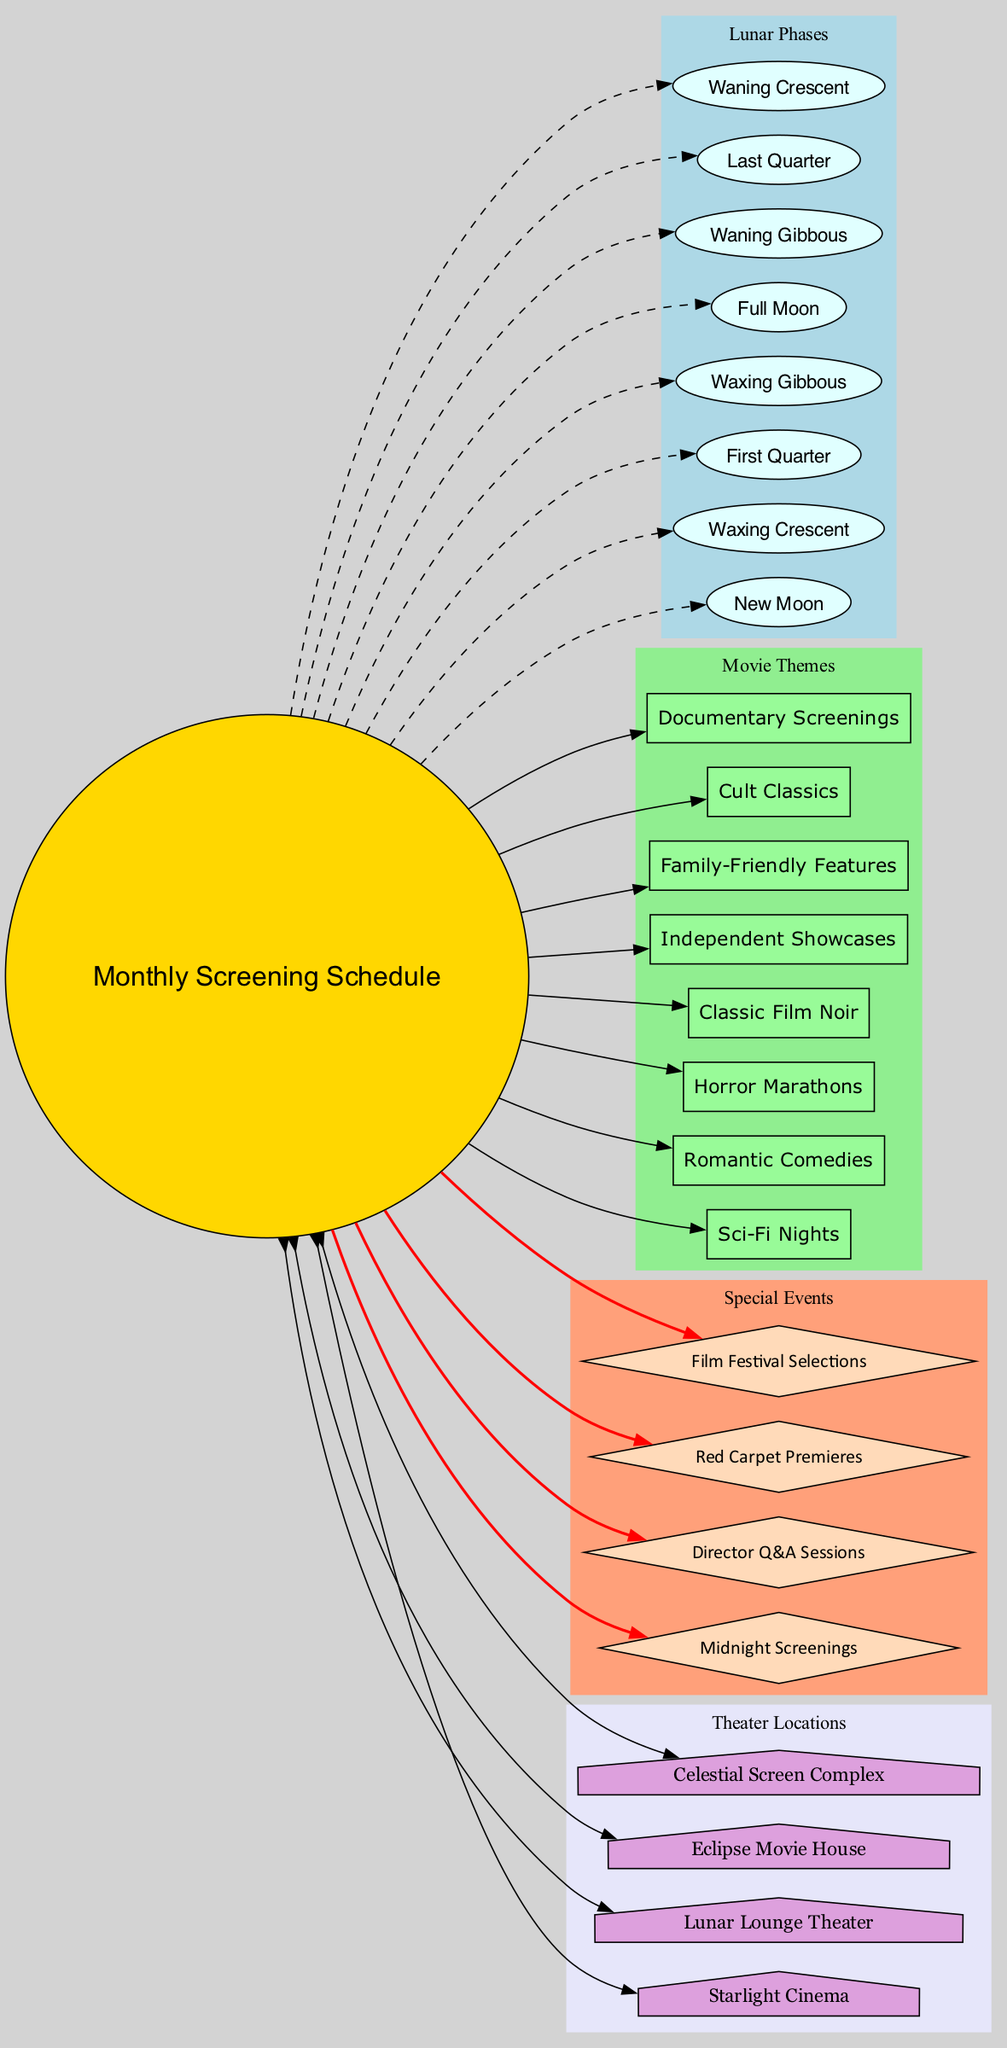What are the lunar phases included in the diagram? The diagram lists eight lunar phases, which are visually represented as individual nodes linked to the center node labeled "Monthly Screening Schedule." The names of the phases are clearly identified in light cyan ovals.
Answer: New Moon, Waxing Crescent, First Quarter, Waxing Gibbous, Full Moon, Waning Gibbous, Last Quarter, Waning Crescent How many movie themes are represented in the diagram? Upon inspecting the diagram, there are eight nodes labeled as movie themes. These boxes are filled with pale green color and are connected to the central node.
Answer: Eight Which special event has the most prominent visual cue in the diagram? The special events are displayed in diamond-shaped nodes colored in peach puff. They are connected to the central node with red edges, making them stand out compared to other nodes. The color and shape indicate their importance.
Answer: Director Q&A Sessions Which lunar phase is directly linked to horror marathons in the diagram? The diagram depicts the connection between "Horror Marathons," a movie theme, and one of the lunar phases. A dashed line leads from the "Last Quarter" lunar phase to the "Horror Marathons" theme, indicating this specific connection.
Answer: Last Quarter How many theater locations are illustrated in the diagram? The diagram showcases four theater locations, each represented by a house-shaped node styled in plum color. These nodes connect back to the central node, indicating their relationship with the screening schedule.
Answer: Four What special event is represented as being linked to the "Red Carpet Premieres"? The diamond-shaped node showing "Red Carpet Premieres" is connected to the central node, which signifies that this event is a special occasion in the monthly screening schedule.
Answer: Red Carpet Premieres Which lunar phase is associated with Independent Showcases? The "Independent Showcases" theme is connected to the "Waxing Gibbous" lunar phase in the diagram. This indicates that screenings of independent films are scheduled to align with this particular lunar phase.
Answer: Waxing Gibbous What color represents the theater locations in the diagram? The theater locations are depicted with house-shaped nodes that are filled with plum color. This color coding differentiates them visually from other categories in the diagram.
Answer: Plum 